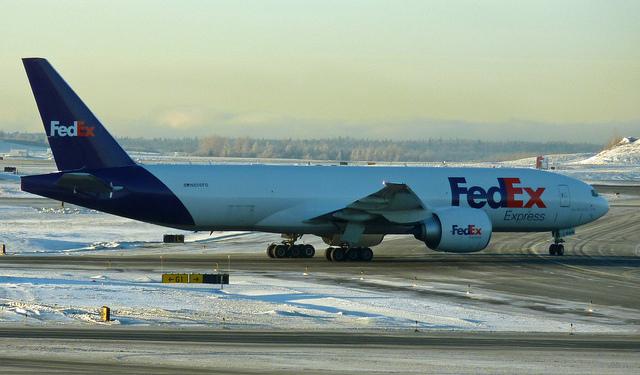What are the words on the plane?
Quick response, please. Fedex. Is this a passenger plane?
Give a very brief answer. No. Is it wintertime?
Answer briefly. Yes. 